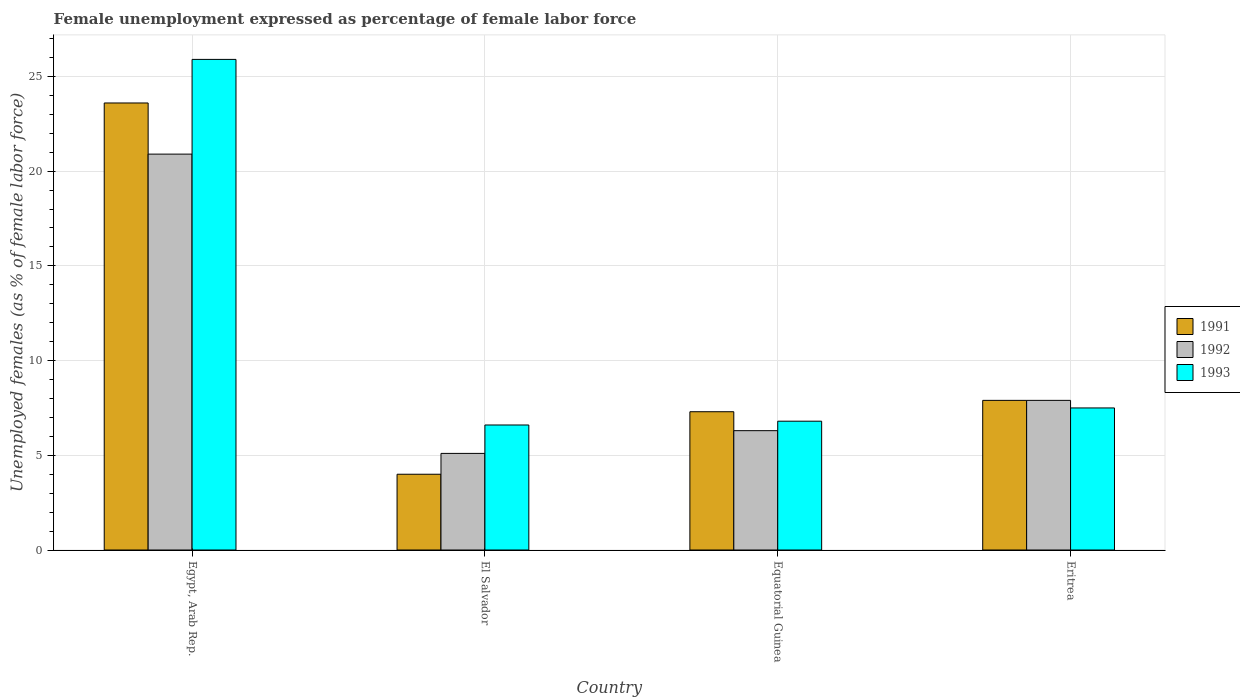How many different coloured bars are there?
Your answer should be very brief. 3. How many groups of bars are there?
Offer a terse response. 4. Are the number of bars on each tick of the X-axis equal?
Provide a short and direct response. Yes. How many bars are there on the 3rd tick from the left?
Provide a short and direct response. 3. How many bars are there on the 4th tick from the right?
Give a very brief answer. 3. What is the label of the 3rd group of bars from the left?
Keep it short and to the point. Equatorial Guinea. In how many cases, is the number of bars for a given country not equal to the number of legend labels?
Offer a very short reply. 0. What is the unemployment in females in in 1991 in Egypt, Arab Rep.?
Keep it short and to the point. 23.6. Across all countries, what is the maximum unemployment in females in in 1992?
Provide a short and direct response. 20.9. In which country was the unemployment in females in in 1991 maximum?
Make the answer very short. Egypt, Arab Rep. In which country was the unemployment in females in in 1991 minimum?
Offer a very short reply. El Salvador. What is the total unemployment in females in in 1992 in the graph?
Give a very brief answer. 40.2. What is the difference between the unemployment in females in in 1992 in Equatorial Guinea and that in Eritrea?
Keep it short and to the point. -1.6. What is the difference between the unemployment in females in in 1993 in Eritrea and the unemployment in females in in 1991 in Egypt, Arab Rep.?
Provide a short and direct response. -16.1. What is the average unemployment in females in in 1991 per country?
Ensure brevity in your answer.  10.7. What is the difference between the unemployment in females in of/in 1993 and unemployment in females in of/in 1991 in Equatorial Guinea?
Give a very brief answer. -0.5. In how many countries, is the unemployment in females in in 1991 greater than 6 %?
Your answer should be very brief. 3. What is the ratio of the unemployment in females in in 1993 in Egypt, Arab Rep. to that in El Salvador?
Give a very brief answer. 3.92. Is the unemployment in females in in 1992 in Equatorial Guinea less than that in Eritrea?
Your answer should be compact. Yes. Is the difference between the unemployment in females in in 1993 in Egypt, Arab Rep. and Eritrea greater than the difference between the unemployment in females in in 1991 in Egypt, Arab Rep. and Eritrea?
Provide a succinct answer. Yes. What is the difference between the highest and the second highest unemployment in females in in 1992?
Offer a very short reply. 14.6. What is the difference between the highest and the lowest unemployment in females in in 1991?
Your answer should be very brief. 19.6. In how many countries, is the unemployment in females in in 1993 greater than the average unemployment in females in in 1993 taken over all countries?
Give a very brief answer. 1. Is the sum of the unemployment in females in in 1993 in Egypt, Arab Rep. and El Salvador greater than the maximum unemployment in females in in 1991 across all countries?
Your answer should be very brief. Yes. What does the 3rd bar from the left in Egypt, Arab Rep. represents?
Offer a terse response. 1993. What does the 2nd bar from the right in Equatorial Guinea represents?
Offer a very short reply. 1992. Is it the case that in every country, the sum of the unemployment in females in in 1992 and unemployment in females in in 1993 is greater than the unemployment in females in in 1991?
Offer a very short reply. Yes. How many bars are there?
Provide a succinct answer. 12. How many countries are there in the graph?
Provide a short and direct response. 4. What is the difference between two consecutive major ticks on the Y-axis?
Keep it short and to the point. 5. Are the values on the major ticks of Y-axis written in scientific E-notation?
Offer a very short reply. No. Does the graph contain any zero values?
Offer a very short reply. No. Does the graph contain grids?
Provide a succinct answer. Yes. How many legend labels are there?
Your answer should be very brief. 3. What is the title of the graph?
Give a very brief answer. Female unemployment expressed as percentage of female labor force. Does "1975" appear as one of the legend labels in the graph?
Provide a short and direct response. No. What is the label or title of the Y-axis?
Offer a terse response. Unemployed females (as % of female labor force). What is the Unemployed females (as % of female labor force) of 1991 in Egypt, Arab Rep.?
Your answer should be very brief. 23.6. What is the Unemployed females (as % of female labor force) of 1992 in Egypt, Arab Rep.?
Provide a succinct answer. 20.9. What is the Unemployed females (as % of female labor force) in 1993 in Egypt, Arab Rep.?
Make the answer very short. 25.9. What is the Unemployed females (as % of female labor force) of 1992 in El Salvador?
Offer a terse response. 5.1. What is the Unemployed females (as % of female labor force) in 1993 in El Salvador?
Offer a very short reply. 6.6. What is the Unemployed females (as % of female labor force) of 1991 in Equatorial Guinea?
Your answer should be compact. 7.3. What is the Unemployed females (as % of female labor force) of 1992 in Equatorial Guinea?
Ensure brevity in your answer.  6.3. What is the Unemployed females (as % of female labor force) in 1993 in Equatorial Guinea?
Offer a terse response. 6.8. What is the Unemployed females (as % of female labor force) in 1991 in Eritrea?
Make the answer very short. 7.9. What is the Unemployed females (as % of female labor force) of 1992 in Eritrea?
Your answer should be very brief. 7.9. What is the Unemployed females (as % of female labor force) in 1993 in Eritrea?
Offer a very short reply. 7.5. Across all countries, what is the maximum Unemployed females (as % of female labor force) in 1991?
Offer a terse response. 23.6. Across all countries, what is the maximum Unemployed females (as % of female labor force) of 1992?
Your answer should be very brief. 20.9. Across all countries, what is the maximum Unemployed females (as % of female labor force) of 1993?
Offer a very short reply. 25.9. Across all countries, what is the minimum Unemployed females (as % of female labor force) in 1991?
Your answer should be very brief. 4. Across all countries, what is the minimum Unemployed females (as % of female labor force) in 1992?
Offer a terse response. 5.1. Across all countries, what is the minimum Unemployed females (as % of female labor force) of 1993?
Provide a short and direct response. 6.6. What is the total Unemployed females (as % of female labor force) of 1991 in the graph?
Keep it short and to the point. 42.8. What is the total Unemployed females (as % of female labor force) of 1992 in the graph?
Make the answer very short. 40.2. What is the total Unemployed females (as % of female labor force) in 1993 in the graph?
Offer a very short reply. 46.8. What is the difference between the Unemployed females (as % of female labor force) of 1991 in Egypt, Arab Rep. and that in El Salvador?
Keep it short and to the point. 19.6. What is the difference between the Unemployed females (as % of female labor force) in 1993 in Egypt, Arab Rep. and that in El Salvador?
Your answer should be compact. 19.3. What is the difference between the Unemployed females (as % of female labor force) of 1991 in Egypt, Arab Rep. and that in Eritrea?
Provide a short and direct response. 15.7. What is the difference between the Unemployed females (as % of female labor force) of 1992 in Egypt, Arab Rep. and that in Eritrea?
Offer a very short reply. 13. What is the difference between the Unemployed females (as % of female labor force) in 1991 in El Salvador and that in Equatorial Guinea?
Keep it short and to the point. -3.3. What is the difference between the Unemployed females (as % of female labor force) of 1992 in El Salvador and that in Equatorial Guinea?
Provide a succinct answer. -1.2. What is the difference between the Unemployed females (as % of female labor force) of 1991 in El Salvador and that in Eritrea?
Your response must be concise. -3.9. What is the difference between the Unemployed females (as % of female labor force) of 1992 in El Salvador and that in Eritrea?
Provide a short and direct response. -2.8. What is the difference between the Unemployed females (as % of female labor force) in 1993 in El Salvador and that in Eritrea?
Provide a short and direct response. -0.9. What is the difference between the Unemployed females (as % of female labor force) in 1992 in Equatorial Guinea and that in Eritrea?
Your answer should be very brief. -1.6. What is the difference between the Unemployed females (as % of female labor force) in 1993 in Equatorial Guinea and that in Eritrea?
Keep it short and to the point. -0.7. What is the difference between the Unemployed females (as % of female labor force) in 1991 in Egypt, Arab Rep. and the Unemployed females (as % of female labor force) in 1992 in El Salvador?
Your response must be concise. 18.5. What is the difference between the Unemployed females (as % of female labor force) in 1991 in Egypt, Arab Rep. and the Unemployed females (as % of female labor force) in 1993 in El Salvador?
Make the answer very short. 17. What is the difference between the Unemployed females (as % of female labor force) of 1992 in Egypt, Arab Rep. and the Unemployed females (as % of female labor force) of 1993 in El Salvador?
Your response must be concise. 14.3. What is the difference between the Unemployed females (as % of female labor force) in 1991 in Egypt, Arab Rep. and the Unemployed females (as % of female labor force) in 1992 in Equatorial Guinea?
Provide a succinct answer. 17.3. What is the difference between the Unemployed females (as % of female labor force) of 1991 in Egypt, Arab Rep. and the Unemployed females (as % of female labor force) of 1993 in Equatorial Guinea?
Provide a short and direct response. 16.8. What is the difference between the Unemployed females (as % of female labor force) in 1991 in Egypt, Arab Rep. and the Unemployed females (as % of female labor force) in 1993 in Eritrea?
Offer a very short reply. 16.1. What is the difference between the Unemployed females (as % of female labor force) in 1991 in El Salvador and the Unemployed females (as % of female labor force) in 1992 in Equatorial Guinea?
Give a very brief answer. -2.3. What is the difference between the Unemployed females (as % of female labor force) in 1991 in El Salvador and the Unemployed females (as % of female labor force) in 1992 in Eritrea?
Offer a very short reply. -3.9. What is the difference between the Unemployed females (as % of female labor force) in 1991 in Equatorial Guinea and the Unemployed females (as % of female labor force) in 1992 in Eritrea?
Your answer should be compact. -0.6. What is the difference between the Unemployed females (as % of female labor force) in 1992 in Equatorial Guinea and the Unemployed females (as % of female labor force) in 1993 in Eritrea?
Give a very brief answer. -1.2. What is the average Unemployed females (as % of female labor force) in 1992 per country?
Your answer should be compact. 10.05. What is the difference between the Unemployed females (as % of female labor force) of 1992 and Unemployed females (as % of female labor force) of 1993 in Egypt, Arab Rep.?
Offer a terse response. -5. What is the difference between the Unemployed females (as % of female labor force) in 1991 and Unemployed females (as % of female labor force) in 1992 in El Salvador?
Your answer should be very brief. -1.1. What is the difference between the Unemployed females (as % of female labor force) of 1991 and Unemployed females (as % of female labor force) of 1993 in El Salvador?
Provide a short and direct response. -2.6. What is the difference between the Unemployed females (as % of female labor force) of 1991 and Unemployed females (as % of female labor force) of 1993 in Eritrea?
Give a very brief answer. 0.4. What is the difference between the Unemployed females (as % of female labor force) in 1992 and Unemployed females (as % of female labor force) in 1993 in Eritrea?
Keep it short and to the point. 0.4. What is the ratio of the Unemployed females (as % of female labor force) of 1992 in Egypt, Arab Rep. to that in El Salvador?
Ensure brevity in your answer.  4.1. What is the ratio of the Unemployed females (as % of female labor force) in 1993 in Egypt, Arab Rep. to that in El Salvador?
Provide a succinct answer. 3.92. What is the ratio of the Unemployed females (as % of female labor force) in 1991 in Egypt, Arab Rep. to that in Equatorial Guinea?
Your response must be concise. 3.23. What is the ratio of the Unemployed females (as % of female labor force) in 1992 in Egypt, Arab Rep. to that in Equatorial Guinea?
Give a very brief answer. 3.32. What is the ratio of the Unemployed females (as % of female labor force) of 1993 in Egypt, Arab Rep. to that in Equatorial Guinea?
Ensure brevity in your answer.  3.81. What is the ratio of the Unemployed females (as % of female labor force) in 1991 in Egypt, Arab Rep. to that in Eritrea?
Offer a terse response. 2.99. What is the ratio of the Unemployed females (as % of female labor force) in 1992 in Egypt, Arab Rep. to that in Eritrea?
Offer a very short reply. 2.65. What is the ratio of the Unemployed females (as % of female labor force) in 1993 in Egypt, Arab Rep. to that in Eritrea?
Give a very brief answer. 3.45. What is the ratio of the Unemployed females (as % of female labor force) in 1991 in El Salvador to that in Equatorial Guinea?
Provide a short and direct response. 0.55. What is the ratio of the Unemployed females (as % of female labor force) of 1992 in El Salvador to that in Equatorial Guinea?
Your answer should be compact. 0.81. What is the ratio of the Unemployed females (as % of female labor force) in 1993 in El Salvador to that in Equatorial Guinea?
Your answer should be very brief. 0.97. What is the ratio of the Unemployed females (as % of female labor force) of 1991 in El Salvador to that in Eritrea?
Provide a succinct answer. 0.51. What is the ratio of the Unemployed females (as % of female labor force) of 1992 in El Salvador to that in Eritrea?
Make the answer very short. 0.65. What is the ratio of the Unemployed females (as % of female labor force) in 1991 in Equatorial Guinea to that in Eritrea?
Offer a very short reply. 0.92. What is the ratio of the Unemployed females (as % of female labor force) of 1992 in Equatorial Guinea to that in Eritrea?
Offer a terse response. 0.8. What is the ratio of the Unemployed females (as % of female labor force) in 1993 in Equatorial Guinea to that in Eritrea?
Offer a terse response. 0.91. What is the difference between the highest and the second highest Unemployed females (as % of female labor force) in 1991?
Keep it short and to the point. 15.7. What is the difference between the highest and the second highest Unemployed females (as % of female labor force) of 1992?
Provide a short and direct response. 13. What is the difference between the highest and the second highest Unemployed females (as % of female labor force) in 1993?
Make the answer very short. 18.4. What is the difference between the highest and the lowest Unemployed females (as % of female labor force) of 1991?
Provide a short and direct response. 19.6. What is the difference between the highest and the lowest Unemployed females (as % of female labor force) in 1992?
Provide a short and direct response. 15.8. What is the difference between the highest and the lowest Unemployed females (as % of female labor force) of 1993?
Provide a succinct answer. 19.3. 